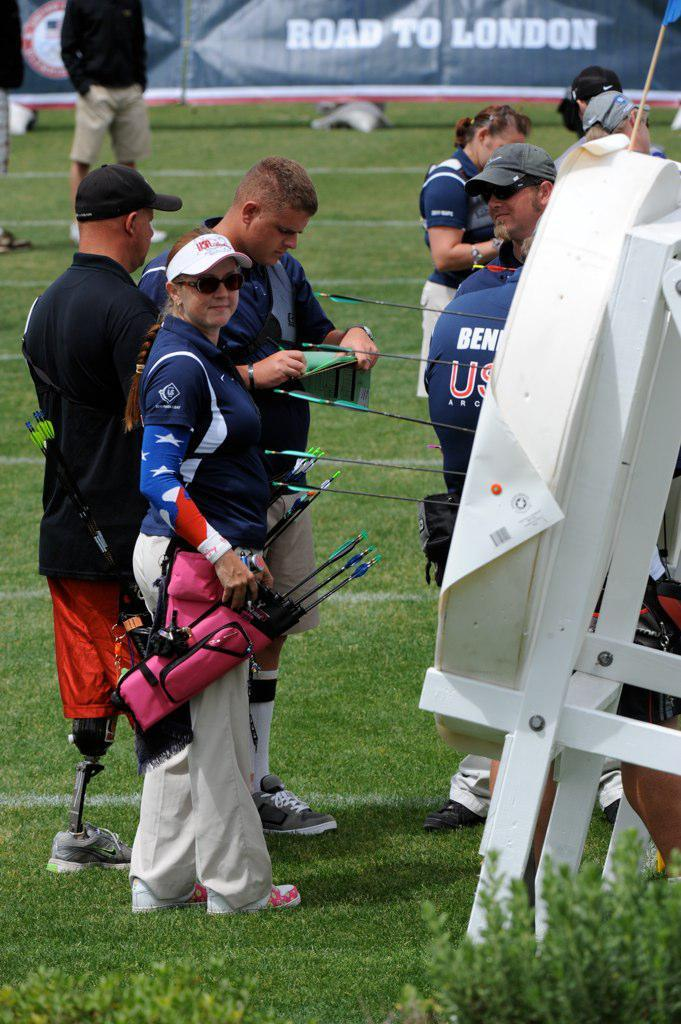Provide a one-sentence caption for the provided image. Some athletes on grass in front of a sign that says "Road to London". 